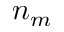Convert formula to latex. <formula><loc_0><loc_0><loc_500><loc_500>n _ { m }</formula> 